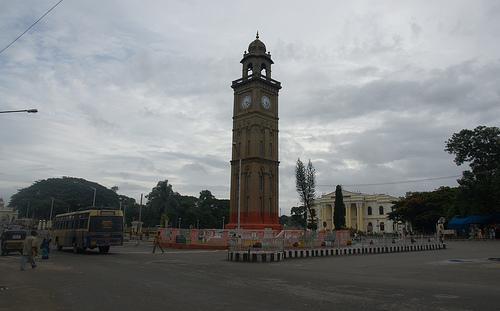How many palm trees are in the picture?
Give a very brief answer. 0. How many cats are sitting on the blanket?
Give a very brief answer. 0. 